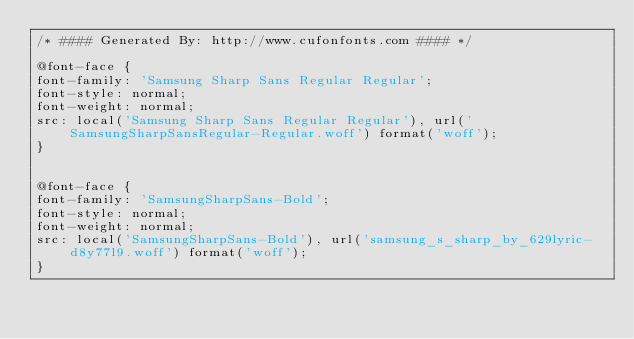<code> <loc_0><loc_0><loc_500><loc_500><_CSS_>/* #### Generated By: http://www.cufonfonts.com #### */

@font-face {
font-family: 'Samsung Sharp Sans Regular Regular';
font-style: normal;
font-weight: normal;
src: local('Samsung Sharp Sans Regular Regular'), url('SamsungSharpSansRegular-Regular.woff') format('woff');
}


@font-face {
font-family: 'SamsungSharpSans-Bold';
font-style: normal;
font-weight: normal;
src: local('SamsungSharpSans-Bold'), url('samsung_s_sharp_by_629lyric-d8y77l9.woff') format('woff');
}</code> 